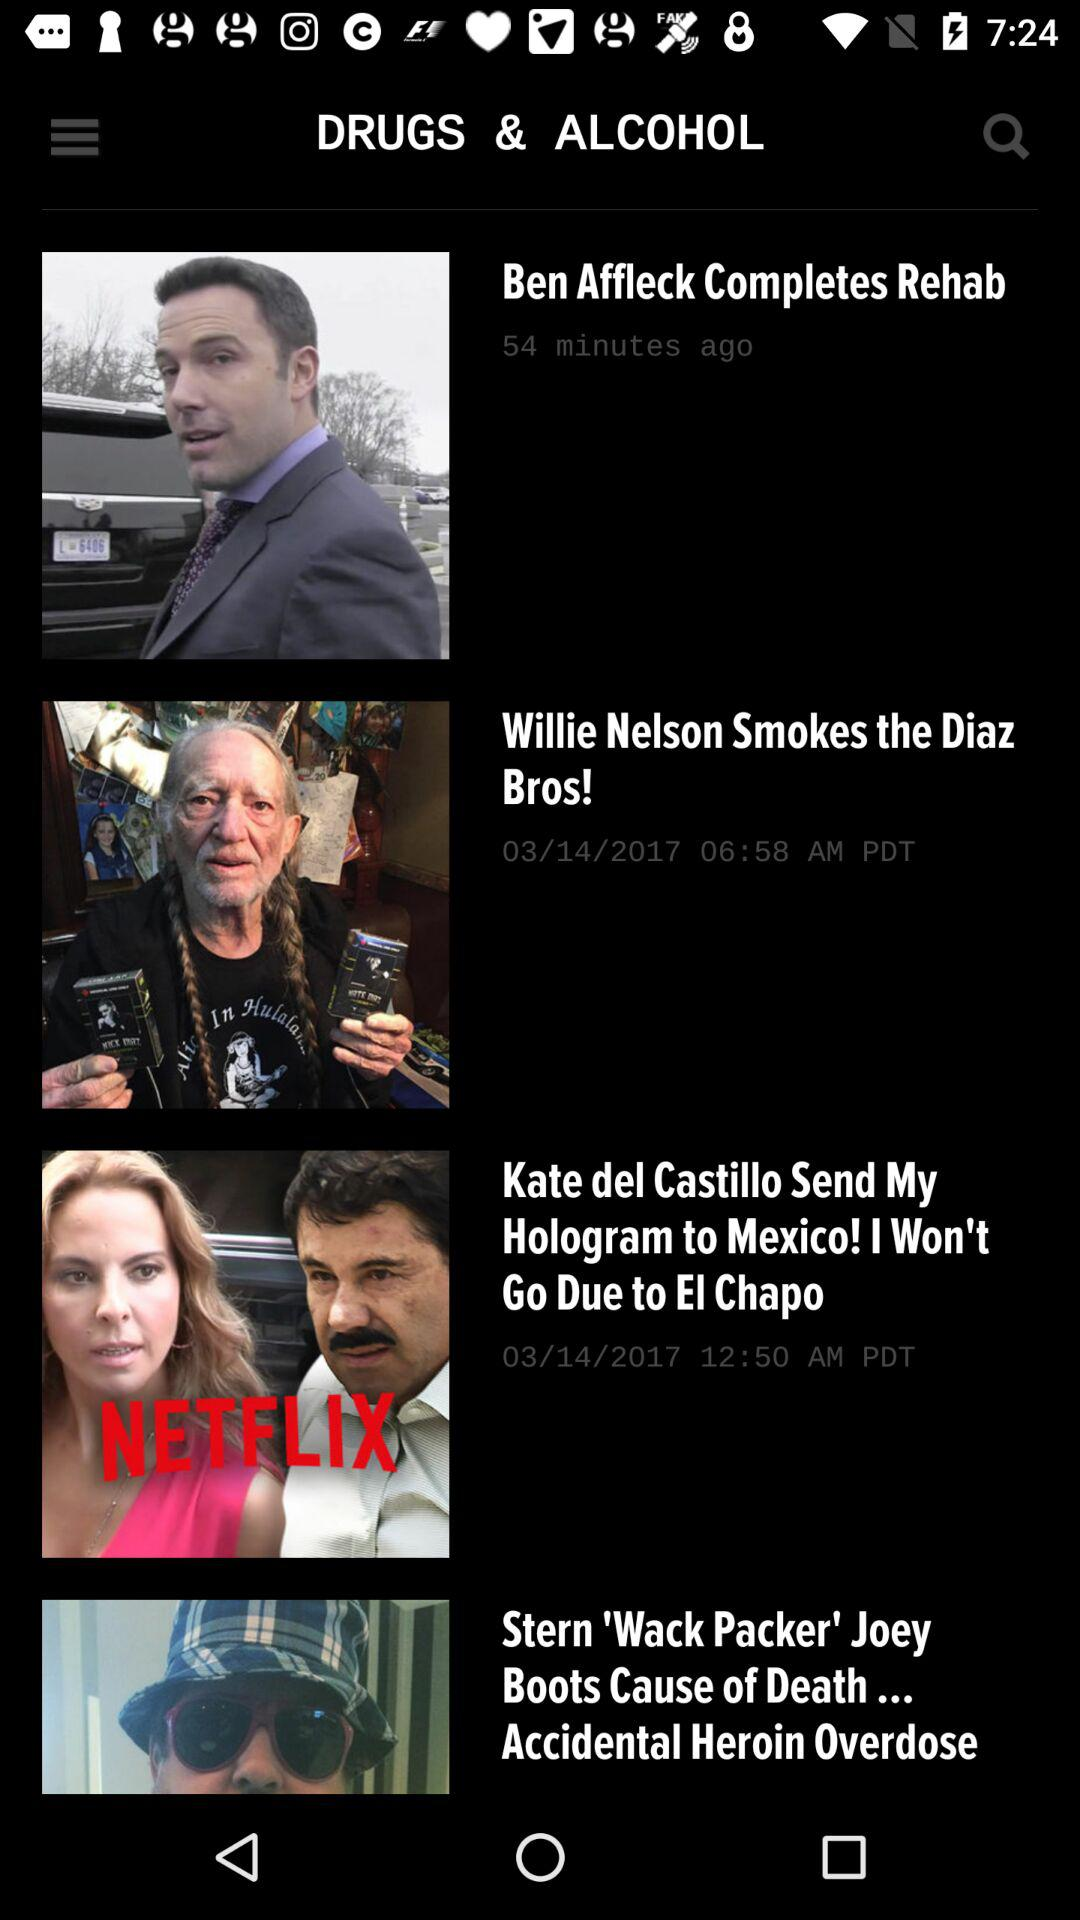When was "Stern 'Wack Packer' Joey Boots Cause of Death... Accidental Heroin Overdose" posted?
When the provided information is insufficient, respond with <no answer>. <no answer> 